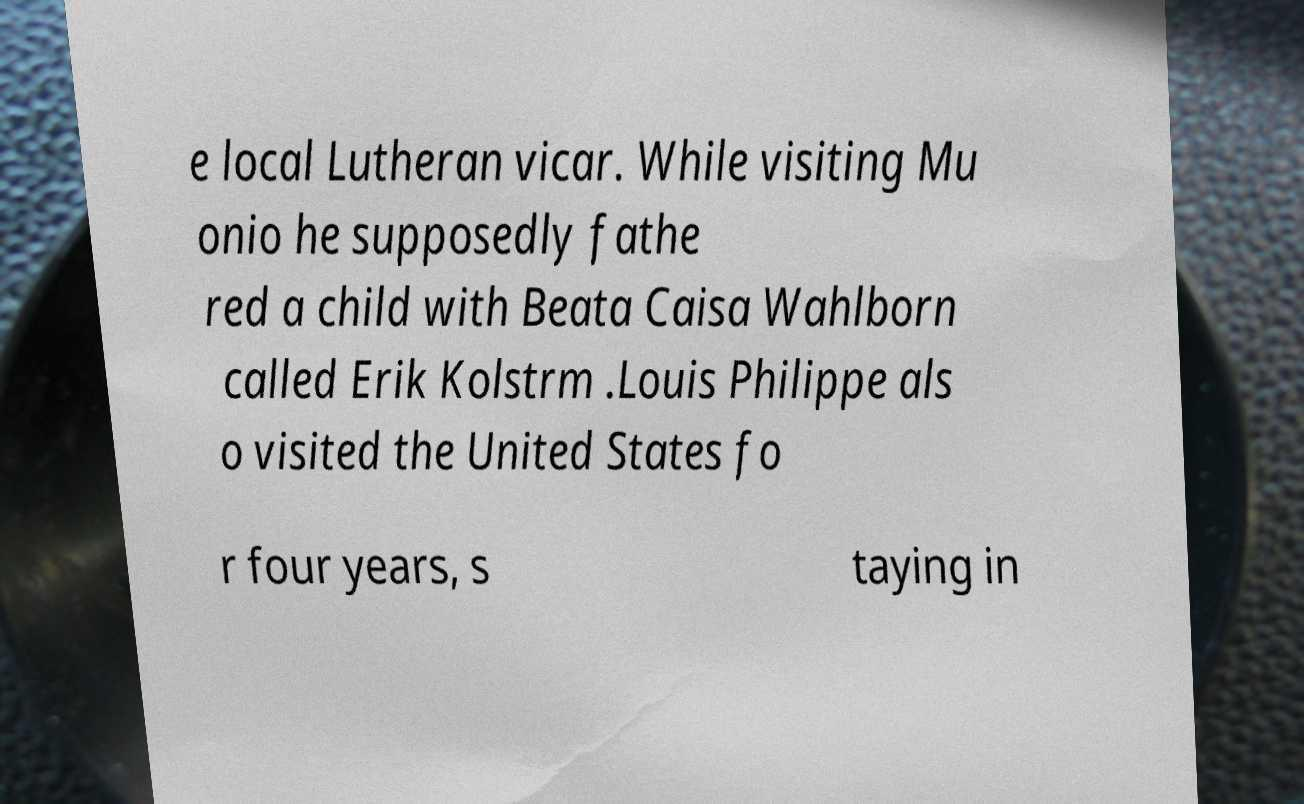I need the written content from this picture converted into text. Can you do that? e local Lutheran vicar. While visiting Mu onio he supposedly fathe red a child with Beata Caisa Wahlborn called Erik Kolstrm .Louis Philippe als o visited the United States fo r four years, s taying in 